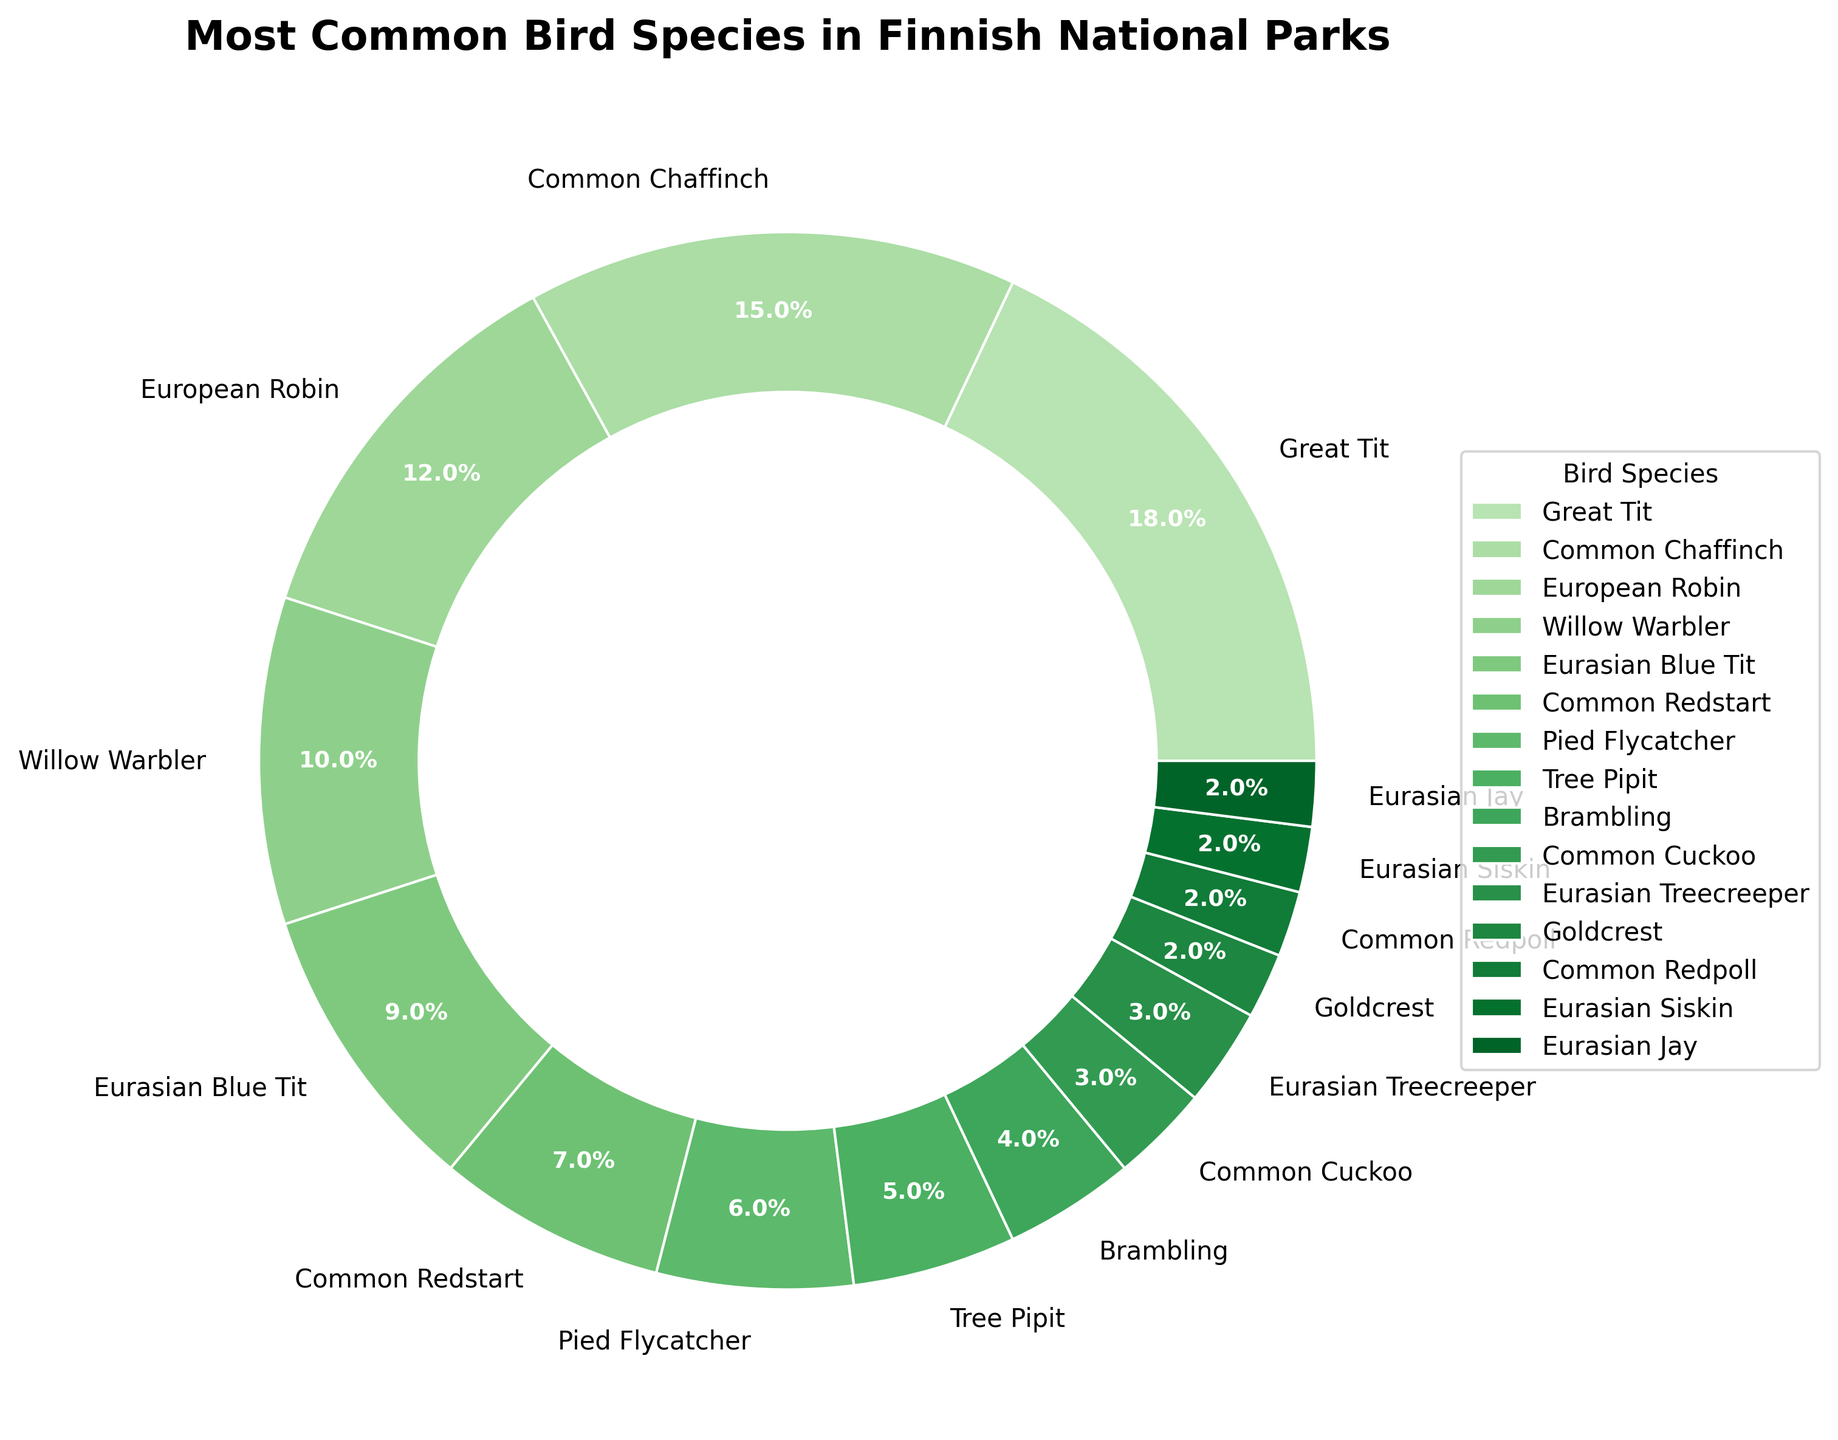What's the bird species with the highest percentage spotted in Finnish national parks? The figure shows each bird species with its corresponding percentage. The species with the highest percentage is visually the largest wedge in the donut chart.
Answer: Great Tit Which bird species have the same percentage of sightings? The figure shows percentages for each bird species. By comparing these, we can see which species have identical percentages.
Answer: Eurasian Treecreeper, Goldcrest, Common Redpoll, Eurasian Siskin, Eurasian Jay What is the combined percentage of sightings for the Great Tit, Common Chaffinch, and European Robin? Add the percentages for Great Tit (18), Common Chaffinch (15), and European Robin (12). So, 18 + 15 + 12 = 45.
Answer: 45 How does the percentage for the Common Redstart compare to that of the Pied Flycatcher? The chart shows the Common Redstart at 7% and the Pied Flycatcher at 6%. Comparing these values, 7% is higher than 6%.
Answer: Common Redstart has a higher percentage Which bird species has a greater percentage, Willow Warbler or Eurasian Blue Tit, and by how much? The chart shows the Willow Warbler at 10% and the Eurasian Blue Tit at 9%. Subtract 9 from 10 to find the difference.
Answer: Willow Warbler by 1% What is the cumulative percentage for species that have at least 10% sightings each? Identify species with 10% or greater: Great Tit (18), Common Chaffinch (15), European Robin (12), Willow Warbler (10). Adding these percentages: 18 + 15 + 12 + 10 = 55.
Answer: 55 How many bird species have a percentage lower than 5%? Count the species with percentages below 5%: Brambling (4), Common Cuckoo (3), Eurasian Treecreeper (3), Goldcrest (2), Common Redpoll (2), Eurasian Siskin (2), Eurasian Jay (2). This gives us 7 species.
Answer: 7 Which bird species is represented by the smallest wedge in the pie chart? The smallest wedge in the donut chart visually corresponds to the smallest percentage.
Answer: Eurasian Jay, Eurasian Siskin, Common Redpoll, Goldcrest What is the visual pattern of the wedges representing bird species with a percentage of 2% each in the pie chart? The pie chart has wedges of similar color shades. Look for the visually smallest and similarly-sized wedges and check their labels.
Answer: Wedges for Goldcrest, Common Redpoll, Eurasian Siskin, Eurasian Jay all have the same small size and similar color in the pie chart 